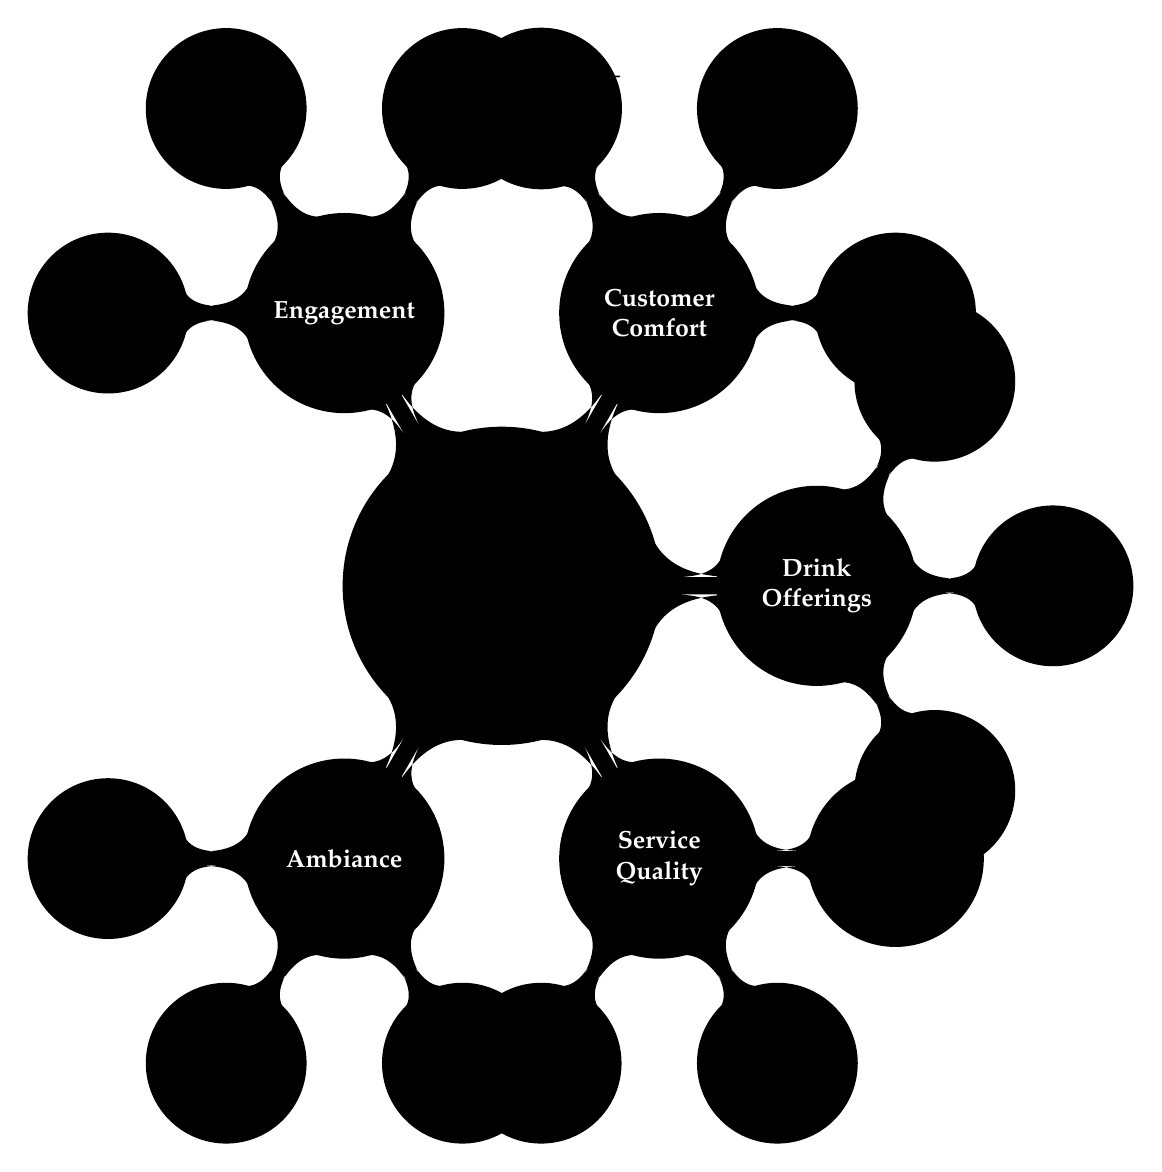What are the three subcategories under Ambiance? The diagram shows three subcategories listed under Ambiance: "Dim Ambient Lighting," "Jazz Background Music," and "Vintage Furniture and Art."
Answer: Dim Ambient Lighting, Jazz Background Music, Vintage Furniture and Art How many nodes are under the Service Quality category? According to the diagram, there are three nodes listed under the Service Quality category: "Warm and Welcoming Staff," "Prompt Drink Serving," and "Bartenders with In-Depth Cocktail Knowledge."
Answer: 3 What is the main focus of the "Drink Offerings" category? The "Drink Offerings" category focuses on three aspects: variety ("Signature and Classic Cocktails"), quality ("Fresh and Premium Ingredients"), and visual appeal ("Creative Garnishes and Glassware").
Answer: Cocktail Variety, Ingredient Quality, Presentation Which category includes "Themed Nights and Live Music"? The "Engagement" category contains the node "Themed Nights and Live Music." It shows that this is how the bar engages customers, through special events.
Answer: Engagement What aspect of the "Customer Comfort" category is highlighted by "Conversation-Friendly Noise Levels"? "Conversation-Friendly Noise Levels" indicates that the bar ensures its acoustics provide a comfortable environment for patrons to converse easily. This highlights the importance of creating a welcoming space in the Customer Comfort category.
Answer: Acoustics 